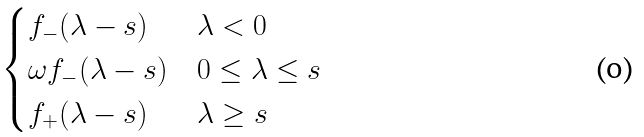<formula> <loc_0><loc_0><loc_500><loc_500>\begin{cases} f _ { - } ( \lambda - s ) & \text {$\lambda<0$} \\ \omega f _ { - } ( \lambda - s ) & \text {$0\leq\lambda\leq s$} \\ f _ { + } ( \lambda - s ) & \text {$\lambda\geq s$} \end{cases}</formula> 